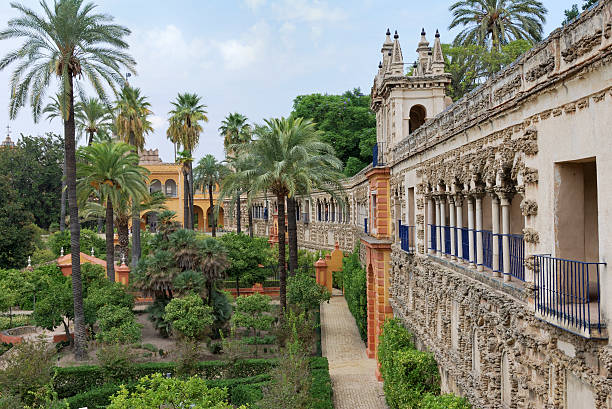What kinds of plants are shown in the gardens, and is there a significance to their arrangement? The gardens in the image seem to host a variety of plants, prominently featuring palm trees that suggest a warm climate. Beneath these, there are neatly sculpted hedges and bushes, likely boxwood or similar evergreens that are easy to shape and thus favored in formal garden designs. The precise arrangement of the plants, with clear pathways and geometric shaping, implies significant attention to symmetry and order. This style of gardening often ties to historical influences, perhaps French or Italian, where gardens were designed to represent control over nature and to reflect the grandeur of the estates they complemented. 